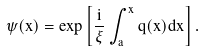<formula> <loc_0><loc_0><loc_500><loc_500>\psi ( x ) = \exp \left [ \frac { i } { \xi } \int _ { a } ^ { x } { q ( x ) d x } \right ] .</formula> 